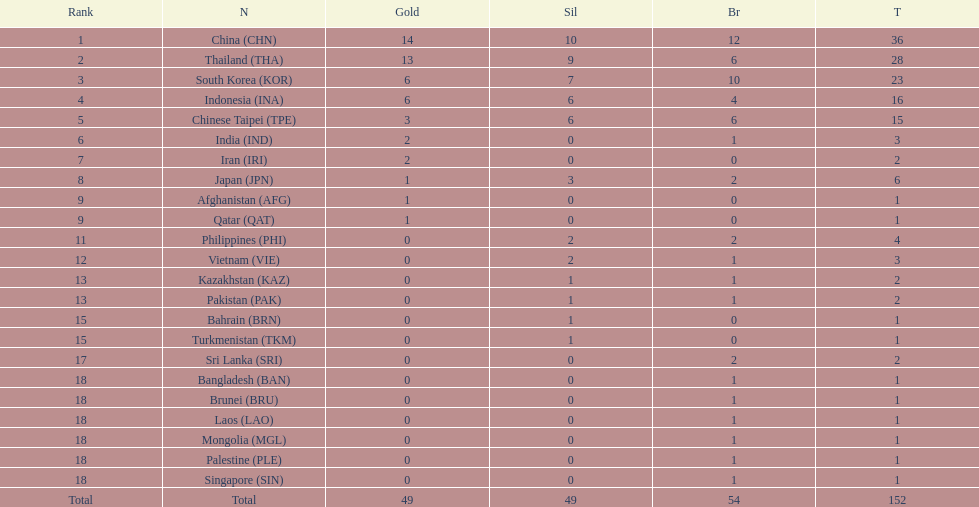How many nations received a medal in each gold, silver, and bronze? 6. 